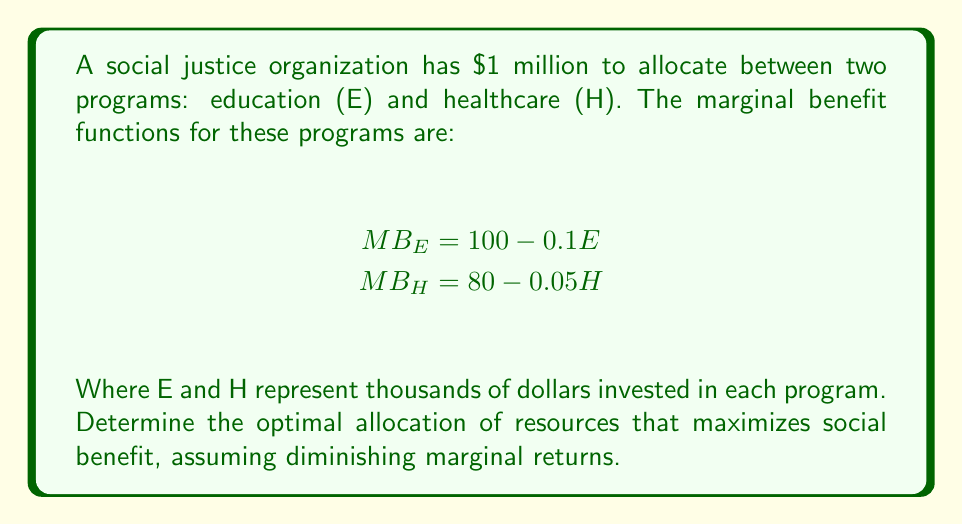Give your solution to this math problem. To find the optimal allocation, we need to equate the marginal benefits of both programs:

1) Set the marginal benefits equal:
   $MB_E = MB_H$
   $100 - 0.1E = 80 - 0.05H$

2) We know that the total budget is $1 million, so:
   $E + H = 1000$ (since E and H are in thousands)

3) Solve the first equation for H:
   $100 - 0.1E = 80 - 0.05H$
   $-0.1E + 0.05H = -20$
   $0.05H = 0.1E - 20$
   $H = 2E - 400$

4) Substitute this into the budget constraint:
   $E + (2E - 400) = 1000$
   $3E - 400 = 1000$
   $3E = 1400$
   $E = 466.67$

5) Calculate H:
   $H = 1000 - 466.67 = 533.33$

6) Verify by checking marginal benefits:
   $MB_E = 100 - 0.1(466.67) = 53.33$
   $MB_H = 80 - 0.05(533.33) = 53.33$

The marginal benefits are equal, confirming the optimal allocation.
Answer: Education: $466,670; Healthcare: $533,330 